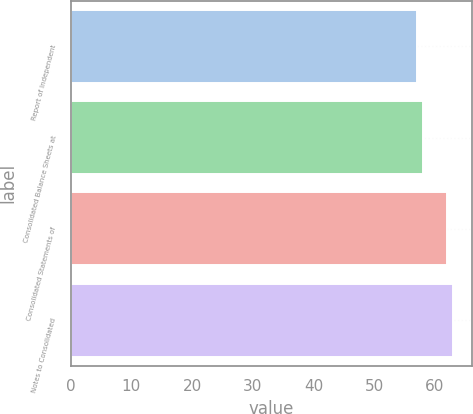Convert chart. <chart><loc_0><loc_0><loc_500><loc_500><bar_chart><fcel>Report of Independent<fcel>Consolidated Balance Sheets at<fcel>Consolidated Statements of<fcel>Notes to Consolidated<nl><fcel>57<fcel>58<fcel>62<fcel>63<nl></chart> 